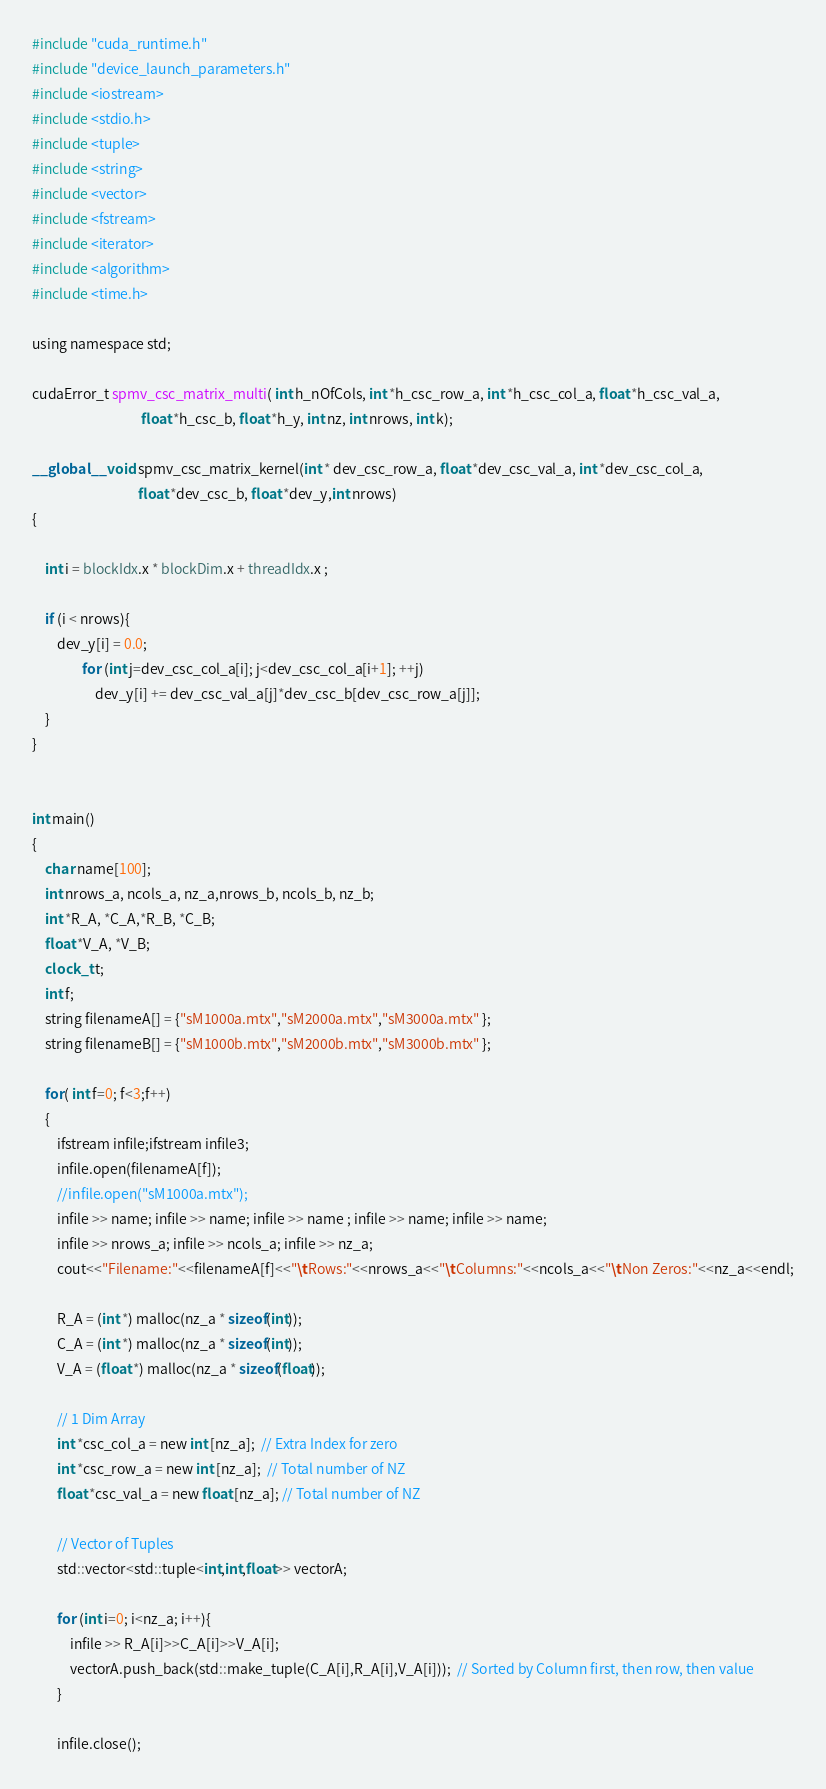Convert code to text. <code><loc_0><loc_0><loc_500><loc_500><_Cuda_>#include "cuda_runtime.h"
#include "device_launch_parameters.h"
#include <iostream>
#include <stdio.h>
#include <tuple>
#include <string>
#include <vector>
#include <fstream>
#include <iterator>
#include <algorithm>
#include <time.h>

using namespace std;

cudaError_t spmv_csc_matrix_multi( int h_nOfCols, int *h_csc_row_a, int *h_csc_col_a, float *h_csc_val_a, 
								   float *h_csc_b, float *h_y, int nz, int nrows, int k);

__global__ void spmv_csc_matrix_kernel(int * dev_csc_row_a, float *dev_csc_val_a, int *dev_csc_col_a, 
								  float *dev_csc_b, float *dev_y,int nrows)
{

	int i = blockIdx.x * blockDim.x + threadIdx.x ;
	
	if (i < nrows){
		dev_y[i] = 0.0;
				for (int j=dev_csc_col_a[i]; j<dev_csc_col_a[i+1]; ++j)
					dev_y[i] += dev_csc_val_a[j]*dev_csc_b[dev_csc_row_a[j]];	
	}
}
	

int main()
{
  	char name[100];	
    int nrows_a, ncols_a, nz_a,nrows_b, ncols_b, nz_b;
    int *R_A, *C_A,*R_B, *C_B;
	float *V_A, *V_B;
	clock_t t;
	int f;
	string filenameA[] = {"sM1000a.mtx","sM2000a.mtx","sM3000a.mtx" };
	string filenameB[] = {"sM1000b.mtx","sM2000b.mtx","sM3000b.mtx" };

	for( int f=0; f<3;f++)
	{
		ifstream infile;ifstream infile3;
		infile.open(filenameA[f]);
		//infile.open("sM1000a.mtx");	
		infile >> name; infile >> name; infile >> name ; infile >> name; infile >> name;
		infile >> nrows_a; infile >> ncols_a; infile >> nz_a;
		cout<<"Filename:"<<filenameA[f]<<"\tRows:"<<nrows_a<<"\tColumns:"<<ncols_a<<"\tNon Zeros:"<<nz_a<<endl;

		R_A = (int *) malloc(nz_a * sizeof(int));
		C_A = (int *) malloc(nz_a * sizeof(int));
		V_A = (float *) malloc(nz_a * sizeof(float));

		// 1 Dim Array
		int *csc_col_a = new int [nz_a];  // Extra Index for zero
		int *csc_row_a = new int [nz_a];  // Total number of NZ
		float *csc_val_a = new float [nz_a]; // Total number of NZ
	
		// Vector of Tuples 
		std::vector<std::tuple<int,int,float>> vectorA;

		for (int i=0; i<nz_a; i++){
			infile >> R_A[i]>>C_A[i]>>V_A[i];
			vectorA.push_back(std::make_tuple(C_A[i],R_A[i],V_A[i]));  // Sorted by Column first, then row, then value
		}
	
		infile.close();</code> 